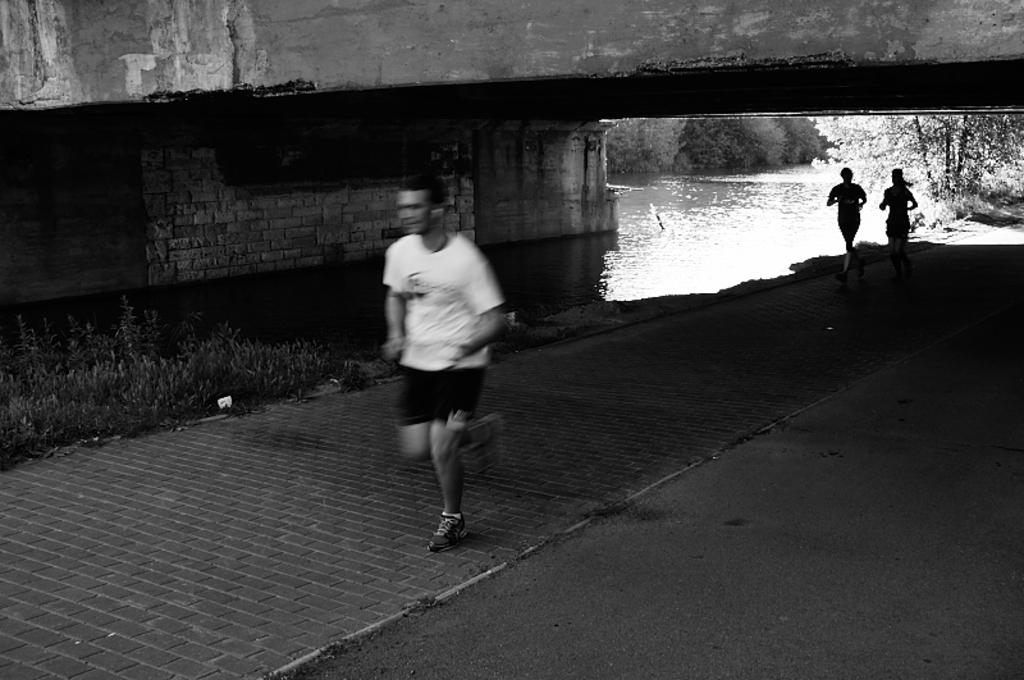How many people are in the image? There are three people in the image. What are the people doing in the image? The people are running on a path. What can be seen on the left side of the image? There are plants on the left side of the image. What structure is present in the image? There is a bridge in the image. What is visible below the bridge? Water is visible below the bridge. What can be seen on the right side of the image? There are trees on the right side of the image. What type of crate is being used to transport the goldfish in the image? There is no crate or goldfish present in the image. 